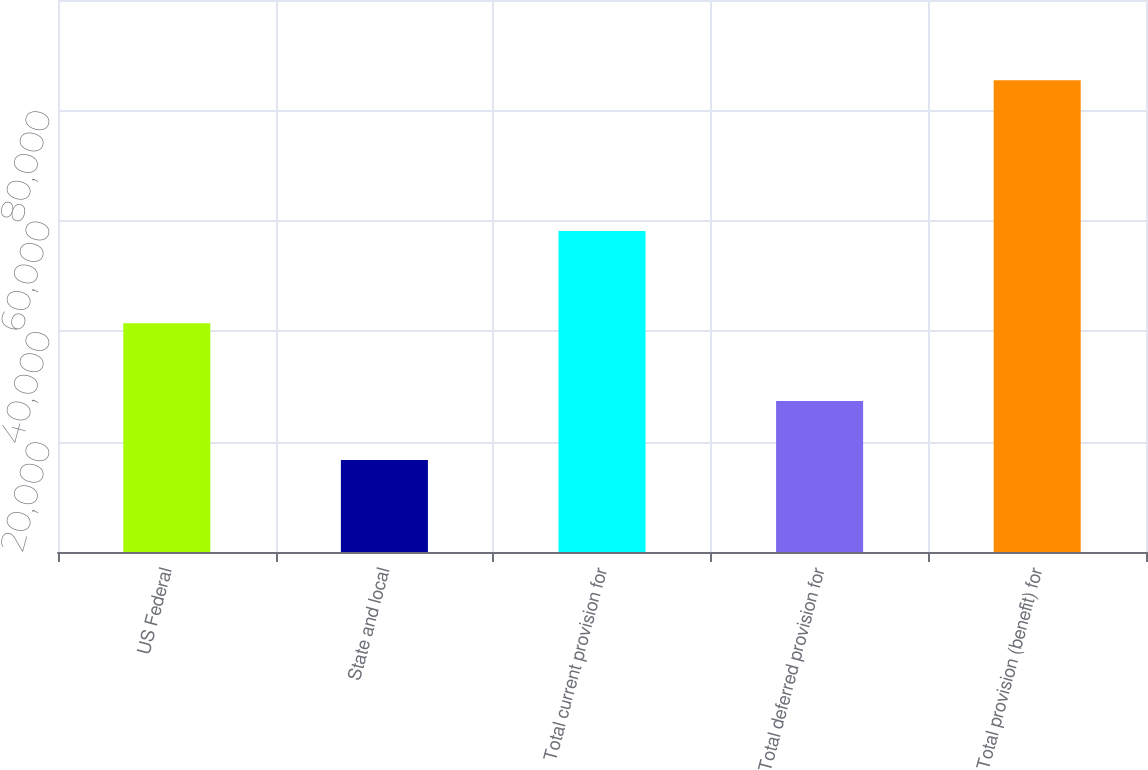Convert chart to OTSL. <chart><loc_0><loc_0><loc_500><loc_500><bar_chart><fcel>US Federal<fcel>State and local<fcel>Total current provision for<fcel>Total deferred provision for<fcel>Total provision (benefit) for<nl><fcel>41452<fcel>16678<fcel>58130<fcel>27347<fcel>85477<nl></chart> 